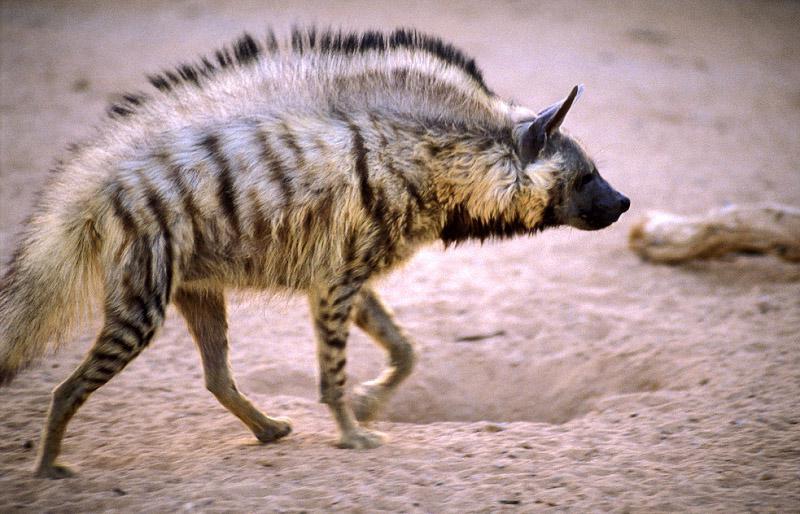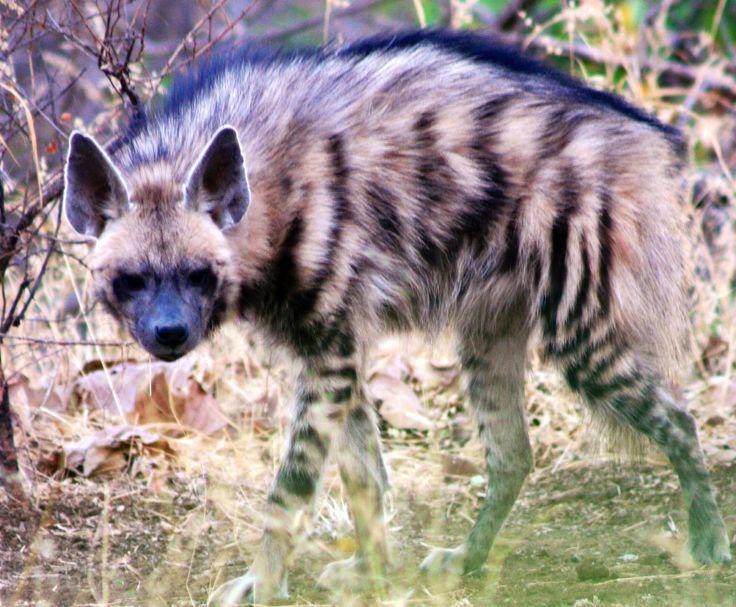The first image is the image on the left, the second image is the image on the right. Examine the images to the left and right. Is the description "The animal in one of the images has its body turned toward the camera." accurate? Answer yes or no. No. The first image is the image on the left, the second image is the image on the right. Considering the images on both sides, is "An image shows only one hyena, with its head and body turned to the camera." valid? Answer yes or no. No. 